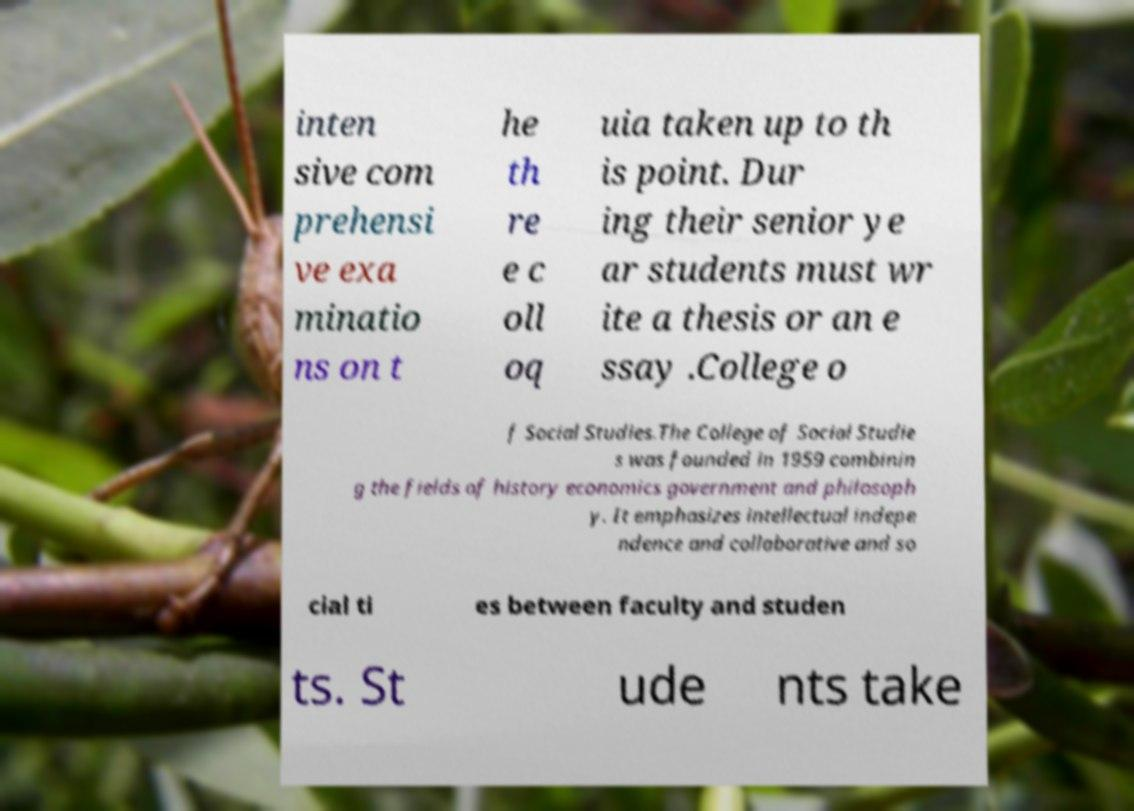Could you extract and type out the text from this image? inten sive com prehensi ve exa minatio ns on t he th re e c oll oq uia taken up to th is point. Dur ing their senior ye ar students must wr ite a thesis or an e ssay .College o f Social Studies.The College of Social Studie s was founded in 1959 combinin g the fields of history economics government and philosoph y. It emphasizes intellectual indepe ndence and collaborative and so cial ti es between faculty and studen ts. St ude nts take 